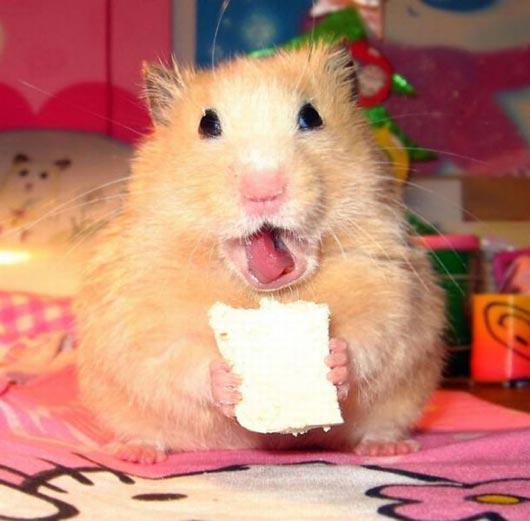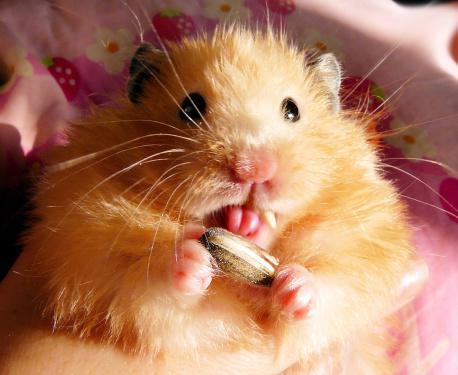The first image is the image on the left, the second image is the image on the right. Examine the images to the left and right. Is the description "The hamster on the left grasps a square treat ready to munch." accurate? Answer yes or no. Yes. 